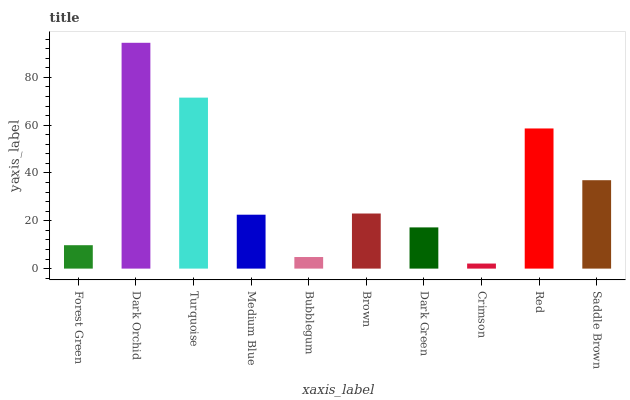Is Crimson the minimum?
Answer yes or no. Yes. Is Dark Orchid the maximum?
Answer yes or no. Yes. Is Turquoise the minimum?
Answer yes or no. No. Is Turquoise the maximum?
Answer yes or no. No. Is Dark Orchid greater than Turquoise?
Answer yes or no. Yes. Is Turquoise less than Dark Orchid?
Answer yes or no. Yes. Is Turquoise greater than Dark Orchid?
Answer yes or no. No. Is Dark Orchid less than Turquoise?
Answer yes or no. No. Is Brown the high median?
Answer yes or no. Yes. Is Medium Blue the low median?
Answer yes or no. Yes. Is Saddle Brown the high median?
Answer yes or no. No. Is Bubblegum the low median?
Answer yes or no. No. 